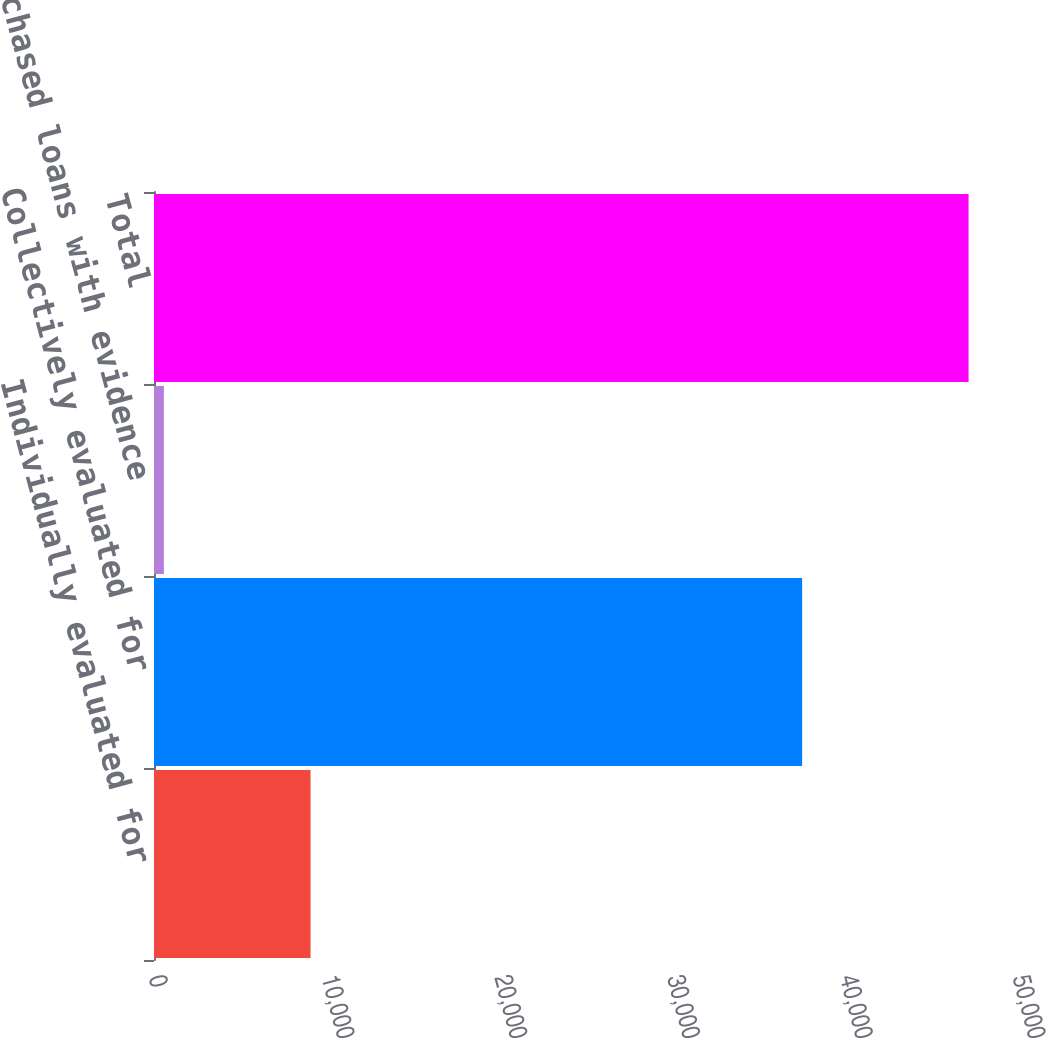Convert chart. <chart><loc_0><loc_0><loc_500><loc_500><bar_chart><fcel>Individually evaluated for<fcel>Collectively evaluated for<fcel>Purchased loans with evidence<fcel>Total<nl><fcel>9059<fcel>37508<fcel>573<fcel>47140<nl></chart> 